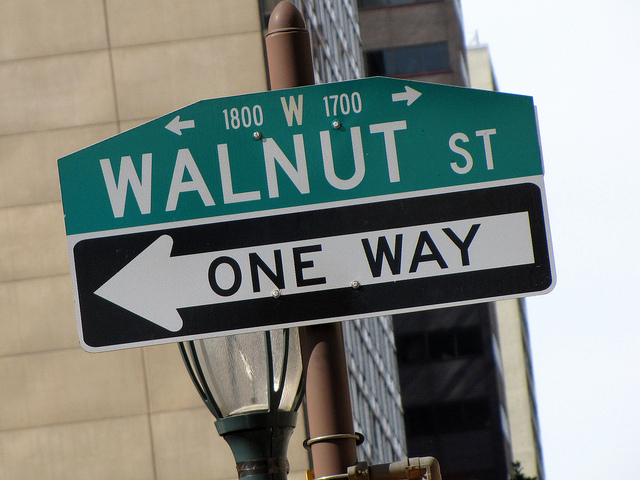Read and extract the text from this image. ST WALNUT WAY ONE W 1700 1800 